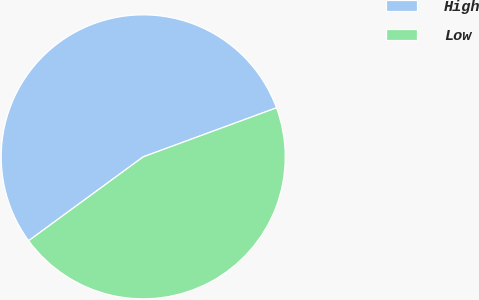Convert chart. <chart><loc_0><loc_0><loc_500><loc_500><pie_chart><fcel>High<fcel>Low<nl><fcel>54.45%<fcel>45.55%<nl></chart> 